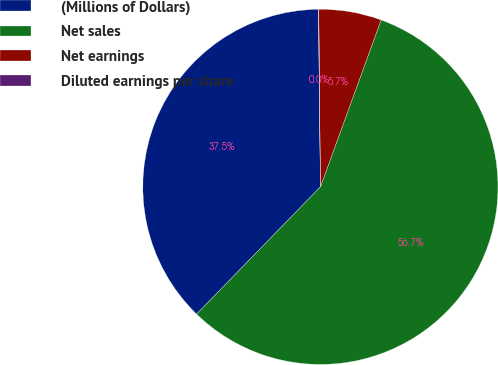<chart> <loc_0><loc_0><loc_500><loc_500><pie_chart><fcel>(Millions of Dollars)<fcel>Net sales<fcel>Net earnings<fcel>Diluted earnings per share<nl><fcel>37.54%<fcel>56.73%<fcel>5.7%<fcel>0.03%<nl></chart> 